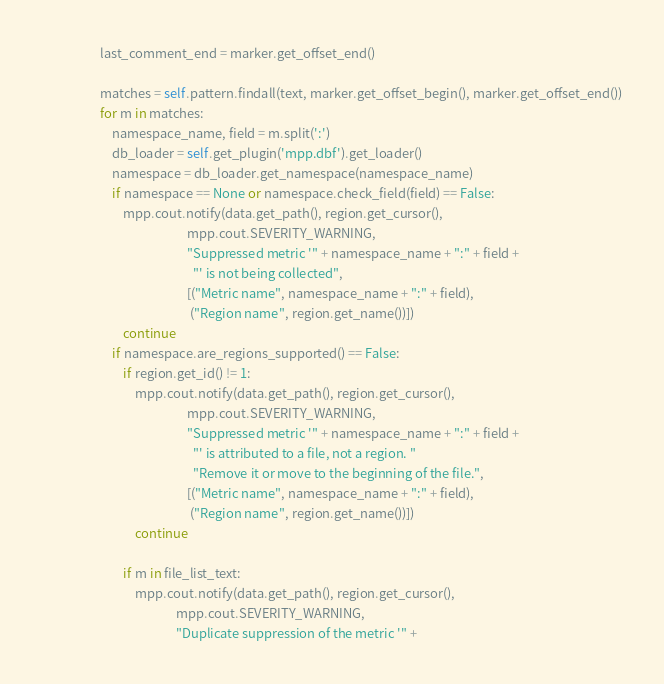<code> <loc_0><loc_0><loc_500><loc_500><_Python_>                    last_comment_end = marker.get_offset_end()
                    
                    matches = self.pattern.findall(text, marker.get_offset_begin(), marker.get_offset_end())
                    for m in matches:
                        namespace_name, field = m.split(':')
                        db_loader = self.get_plugin('mpp.dbf').get_loader()
                        namespace = db_loader.get_namespace(namespace_name)
                        if namespace == None or namespace.check_field(field) == False:
                            mpp.cout.notify(data.get_path(), region.get_cursor(),
                                                  mpp.cout.SEVERITY_WARNING,
                                                  "Suppressed metric '" + namespace_name + ":" + field +
                                                    "' is not being collected",
                                                  [("Metric name", namespace_name + ":" + field),
                                                   ("Region name", region.get_name())])
                            continue
                        if namespace.are_regions_supported() == False:
                            if region.get_id() != 1:
                                mpp.cout.notify(data.get_path(), region.get_cursor(),
                                                  mpp.cout.SEVERITY_WARNING,
                                                  "Suppressed metric '" + namespace_name + ":" + field +
                                                    "' is attributed to a file, not a region. "
                                                    "Remove it or move to the beginning of the file.",
                                                  [("Metric name", namespace_name + ":" + field),
                                                   ("Region name", region.get_name())])
                                continue
                            
                            if m in file_list_text:
                                mpp.cout.notify(data.get_path(), region.get_cursor(),
                                              mpp.cout.SEVERITY_WARNING,
                                              "Duplicate suppression of the metric '" +</code> 